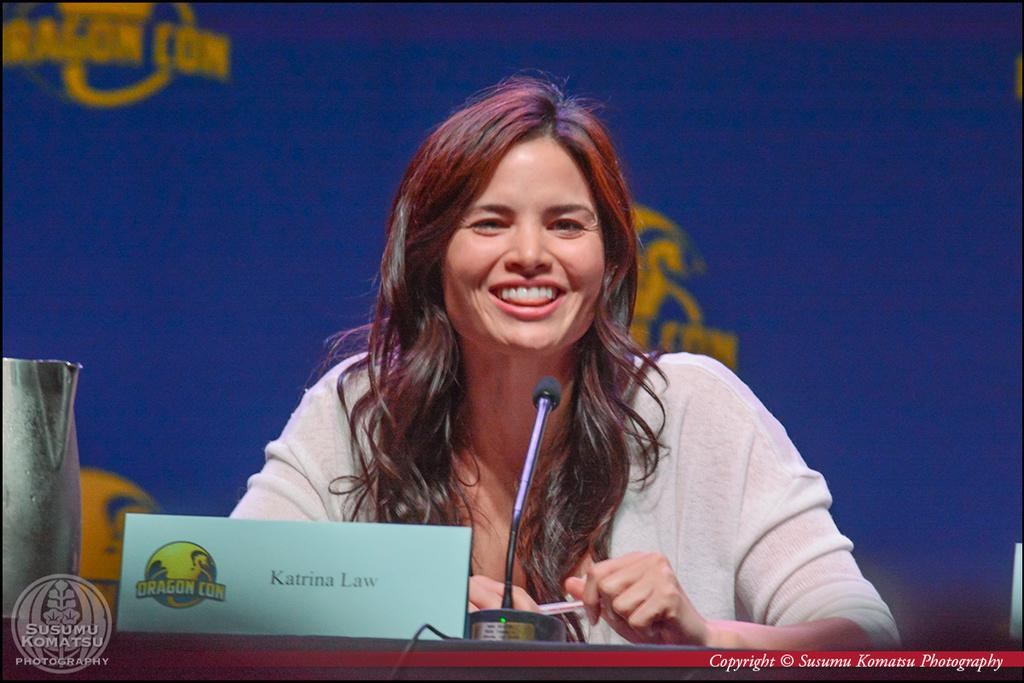What is the main subject of the image? There is a person in the image. Can you describe the person's attire? The person is wearing a white dress. What is the person's facial expression? The person is smiling. What objects are in front of the person? There is a mic, a board, and other objects in front of the person. What can be observed about the background of the image? The background of the image has blue and yellow colors. What type of advice is the person giving in the image? There is no indication in the image that the person is giving advice. Can you hear the sound of the jail in the image? There is no jail present in the image, and therefore no sound associated with it can be heard. 